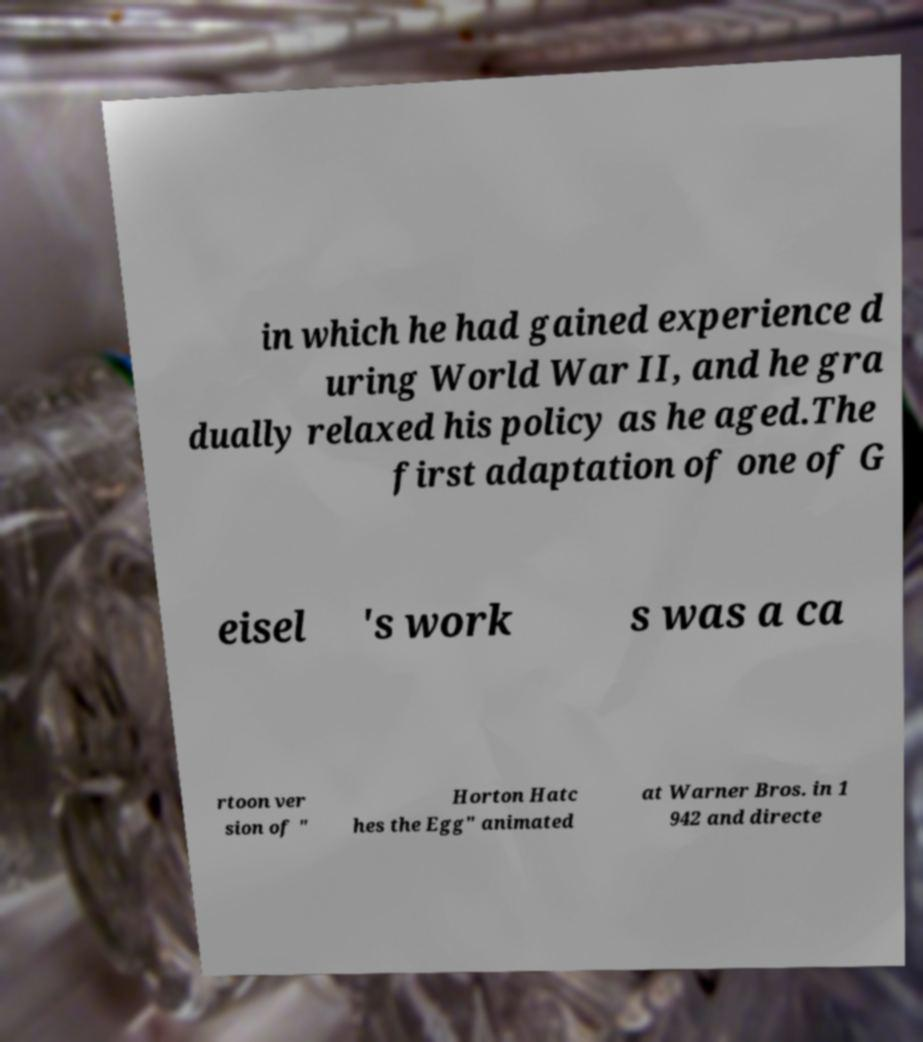Can you read and provide the text displayed in the image?This photo seems to have some interesting text. Can you extract and type it out for me? in which he had gained experience d uring World War II, and he gra dually relaxed his policy as he aged.The first adaptation of one of G eisel 's work s was a ca rtoon ver sion of " Horton Hatc hes the Egg" animated at Warner Bros. in 1 942 and directe 